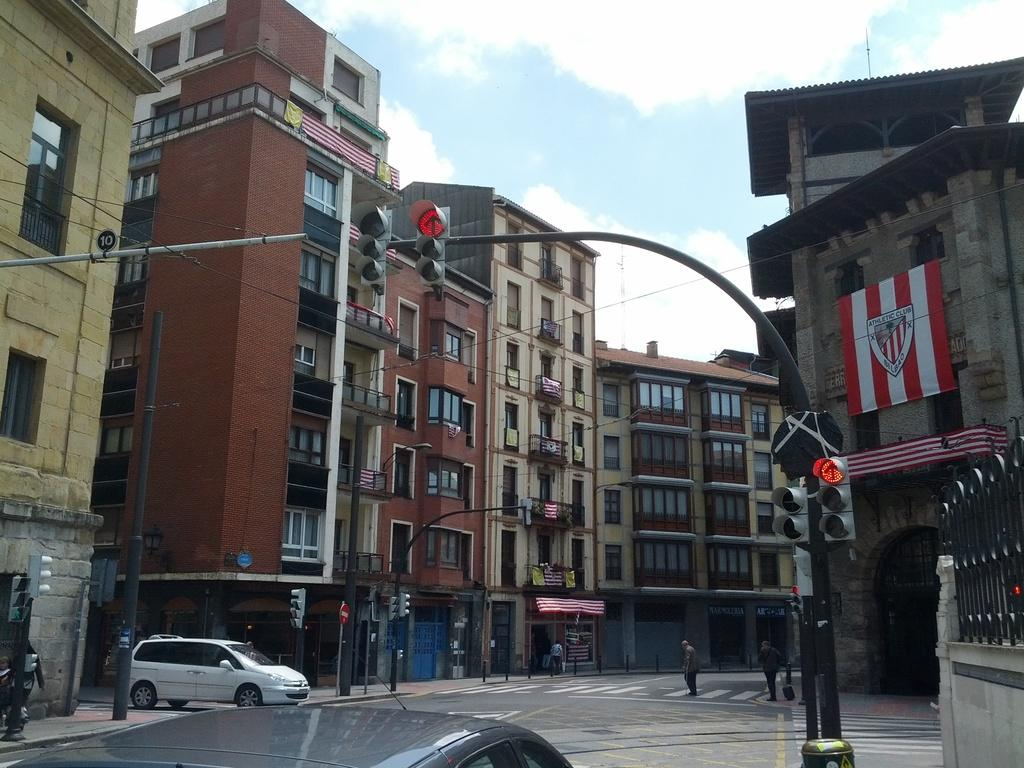What type of pathway is visible in the image? There is a road in the image. What structures can be seen alongside the road? There are buildings in the image. What object is attached to the pole in the image? There is a traffic light in the image. What is attached to the traffic light? There is a flag in the image. What is holding the flag? There is a wire in the image. What part of the natural environment is visible in the image? There is a sky visible in the image. What type of vehicle is present in the image? There is a car in the image. What type of health advice can be seen on the picture in the image? There is no picture present in the image, and therefore no health advice can be observed. Can you tell me how many fowl are crossing the road in the image? There are no fowl present in the image; it features a road, buildings, a pole, a traffic light, a flag, a wire, a sky, and a car. 